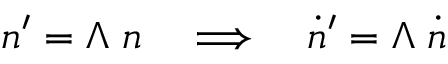<formula> <loc_0><loc_0><loc_500><loc_500>n ^ { \prime } = \Lambda \, n \quad \Longrightarrow \quad \dot { n } ^ { \prime } = \Lambda \, \dot { n }</formula> 